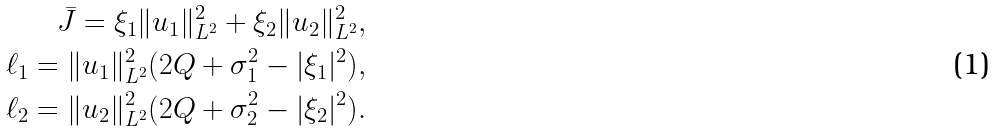<formula> <loc_0><loc_0><loc_500><loc_500>\bar { J } = \xi _ { 1 } \| u _ { 1 } \| _ { L ^ { 2 } } ^ { 2 } + \xi _ { 2 } \| u _ { 2 } \| _ { L ^ { 2 } } ^ { 2 } , \\ \ell _ { 1 } = \| u _ { 1 } \| _ { L ^ { 2 } } ^ { 2 } ( 2 Q + \sigma _ { 1 } ^ { 2 } - | \xi _ { 1 } | ^ { 2 } ) , \\ \ell _ { 2 } = \| u _ { 2 } \| _ { L ^ { 2 } } ^ { 2 } ( 2 Q + \sigma _ { 2 } ^ { 2 } - | \xi _ { 2 } | ^ { 2 } ) .</formula> 